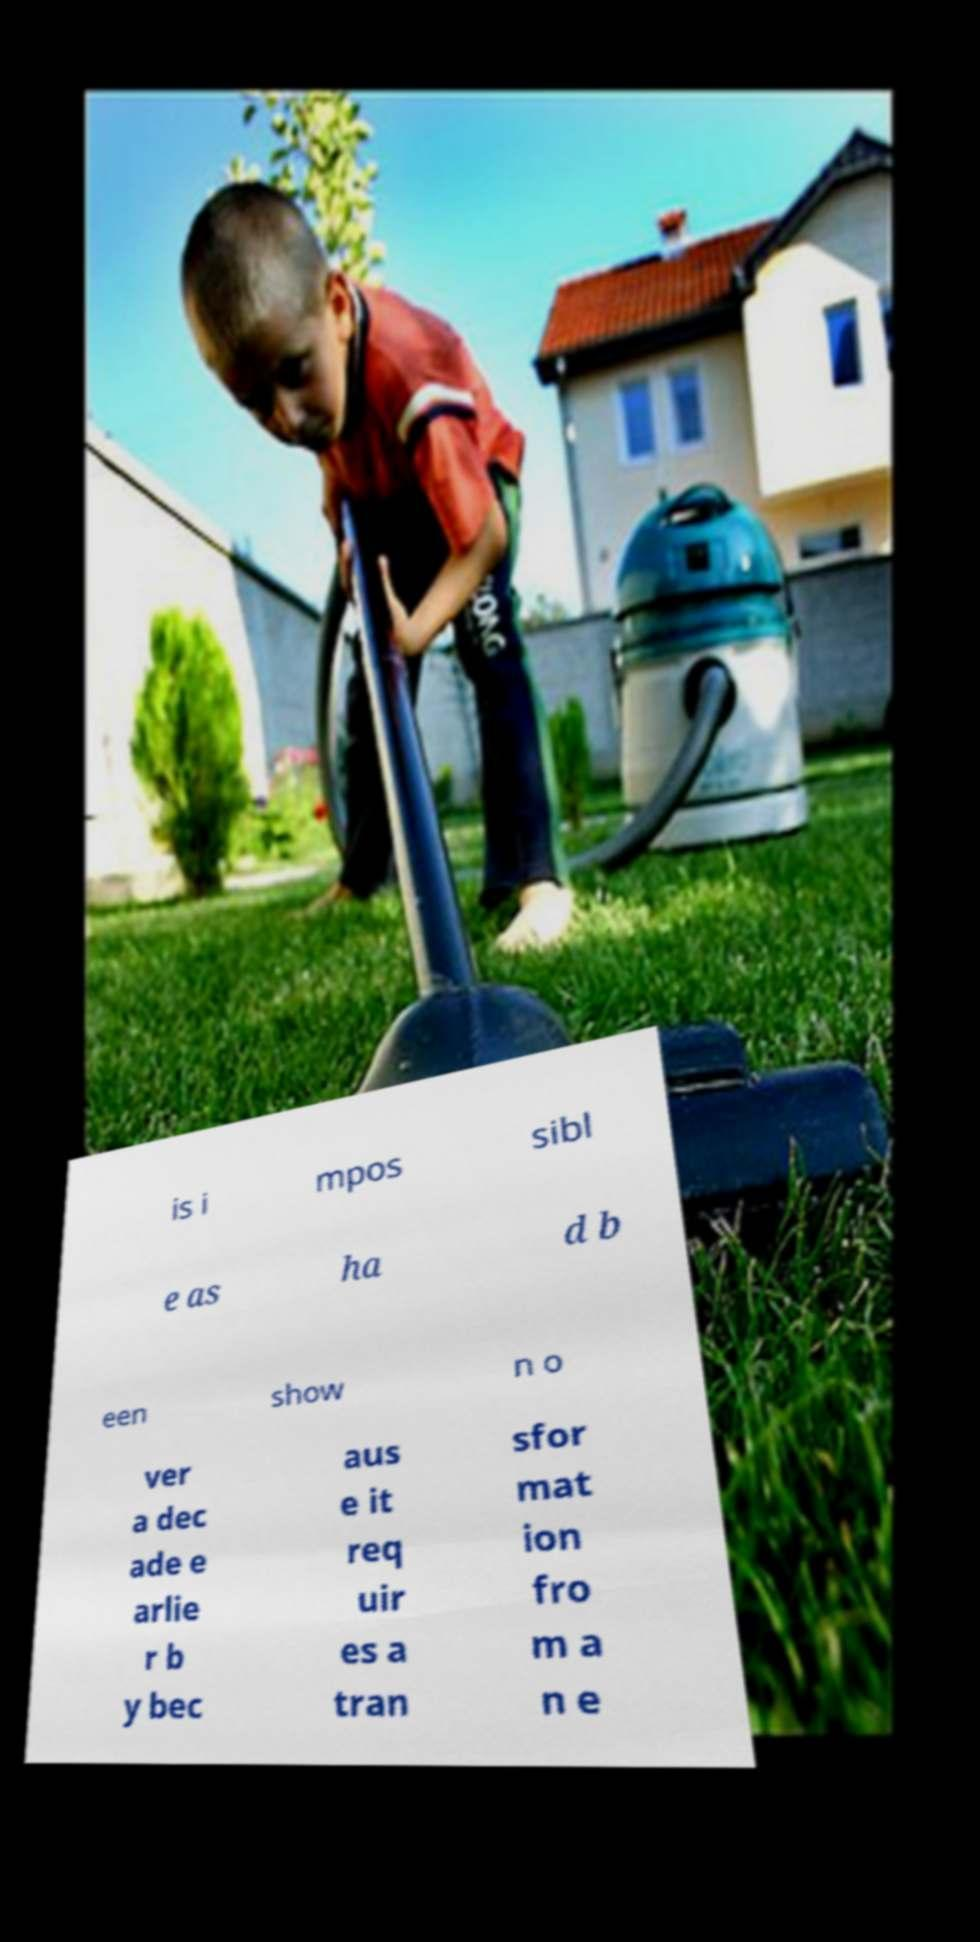Please read and relay the text visible in this image. What does it say? is i mpos sibl e as ha d b een show n o ver a dec ade e arlie r b y bec aus e it req uir es a tran sfor mat ion fro m a n e 